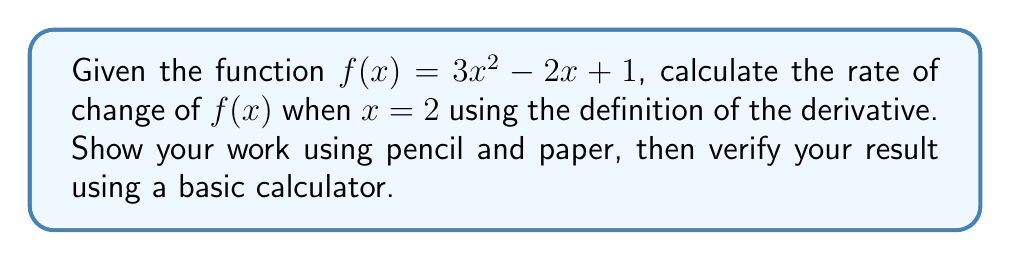Provide a solution to this math problem. To find the rate of change at a specific point, we need to calculate the derivative of the function at that point. We'll use the definition of the derivative:

$$f'(x) = \lim_{h \to 0} \frac{f(x+h) - f(x)}{h}$$

Step 1: Write out the limit expression for $f'(2)$
$$f'(2) = \lim_{h \to 0} \frac{f(2+h) - f(2)}{h}$$

Step 2: Substitute the function into the expression
$$f'(2) = \lim_{h \to 0} \frac{[3(2+h)^2 - 2(2+h) + 1] - [3(2)^2 - 2(2) + 1]}{h}$$

Step 3: Expand the squared term
$$f'(2) = \lim_{h \to 0} \frac{[3(4+4h+h^2) - 2(2+h) + 1] - [12 - 4 + 1]}{h}$$

Step 4: Simplify the numerator
$$f'(2) = \lim_{h \to 0} \frac{[12+12h+3h^2 - 4 - 2h + 1] - 9}{h}$$
$$f'(2) = \lim_{h \to 0} \frac{12h+3h^2 - 2h}{h}$$

Step 5: Factor out $h$ from the numerator
$$f'(2) = \lim_{h \to 0} \frac{h(12+3h - 2)}{h}$$

Step 6: Cancel $h$ from numerator and denominator
$$f'(2) = \lim_{h \to 0} (12+3h - 2)$$

Step 7: Evaluate the limit as $h$ approaches 0
$$f'(2) = 12 + 3(0) - 2 = 10$$

Verify using a calculator:
$f'(x) = 6x - 2$
$f'(2) = 6(2) - 2 = 12 - 2 = 10$
Answer: $10$ 